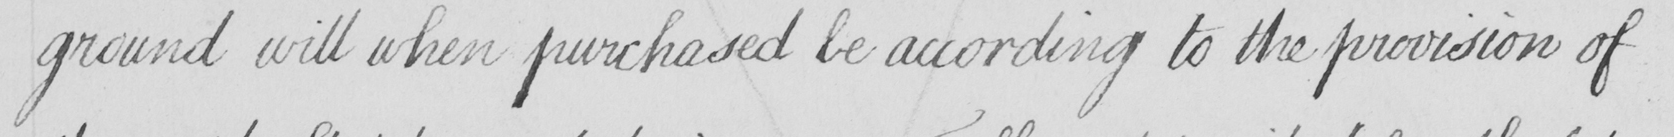Please transcribe the handwritten text in this image. ground will when purchased be according to the provision of 